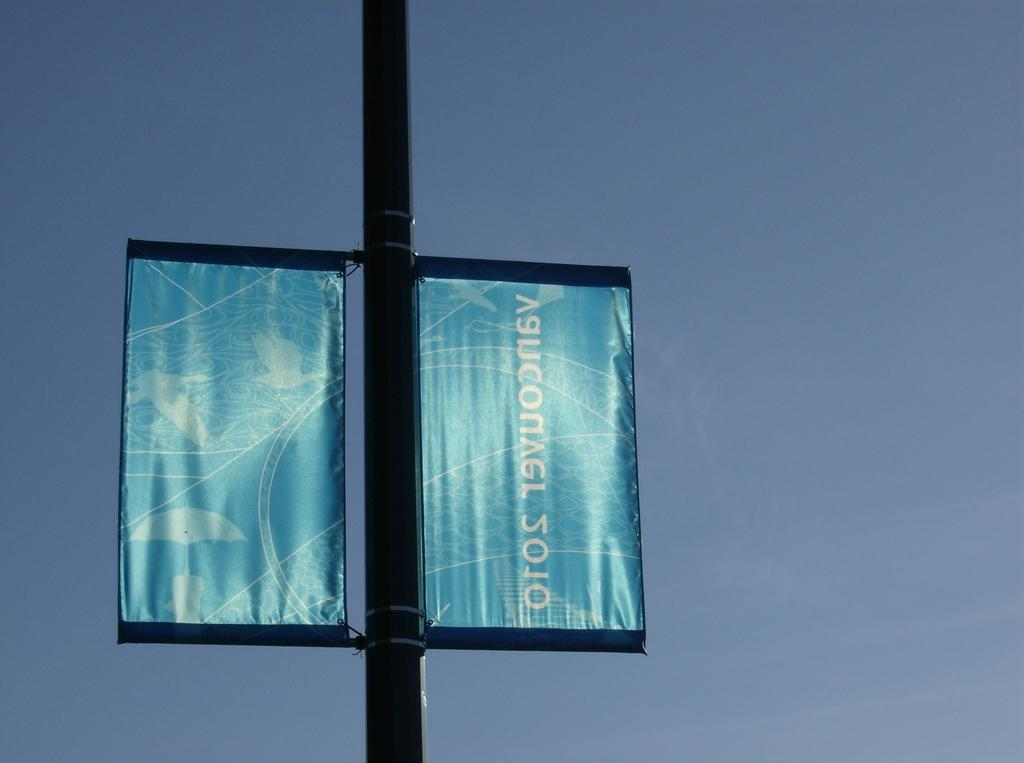What is the main object in the center of the image? There is a pole in the center of the image. What is attached to the pole? Two banners are attached to the pole. What color are the banners? The banners are blue in color. What can be seen in the background of the image? The background of the image contains the sky. What type of notebook is being used to write on the pole in the image? There is no notebook present in the image, and the pole is not being used for writing. 